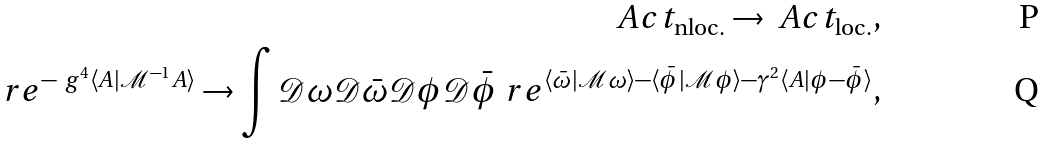Convert formula to latex. <formula><loc_0><loc_0><loc_500><loc_500>\ A c t _ { \text {nloc.} } \to \ A c t _ { \text {loc.} } , \\ \ r e ^ { - \ g ^ { 4 } \langle A | \mathcal { M } ^ { - 1 } A \rangle } \to \int \mathcal { D } \omega \mathcal { D } \bar { \omega } \mathcal { D } \phi \mathcal { D } \bar { \phi } \ r e ^ { \langle \bar { \omega } | \mathcal { M } \omega \rangle - \langle \bar { \phi } | \mathcal { M } \phi \rangle - \gamma ^ { 2 } \langle A | \phi - \bar { \phi } \rangle } ,</formula> 